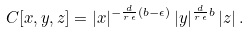<formula> <loc_0><loc_0><loc_500><loc_500>C [ x , y , z ] = | x | ^ { - \frac { d } { r \, \epsilon } ( b - \epsilon ) } \, | y | ^ { \frac { d } { r \, \epsilon } b } \, | z | \, .</formula> 